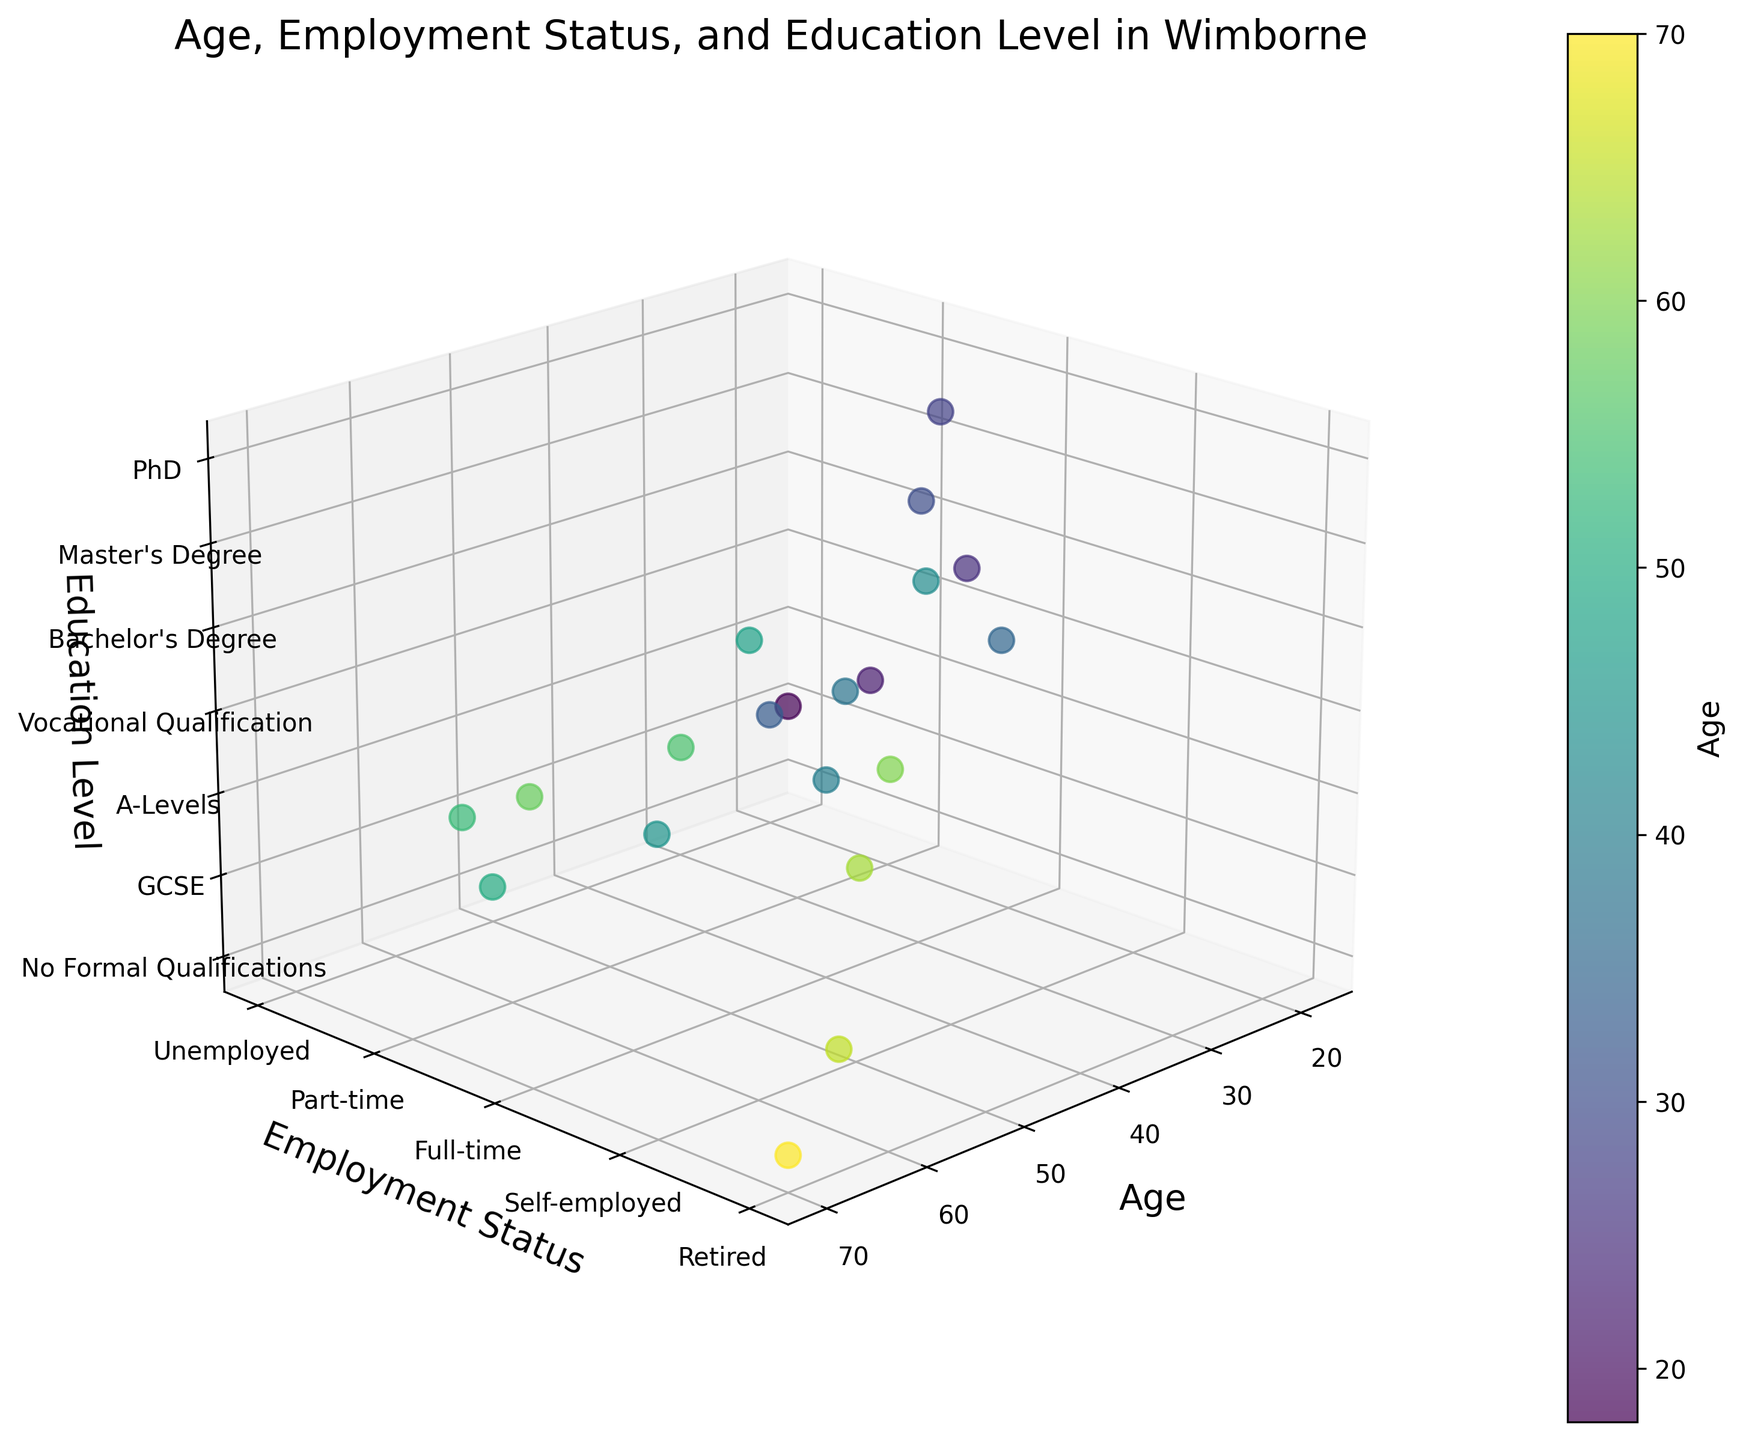What's the title of the figure? The title is located at the top of the figure and often gives a brief description of what the graph is about.
Answer: Age, Employment Status, and Education Level in Wimborne How many employment categories are there in the figure? By looking at the y-axis with labels, there are distinct categories listed for employment status. We count these categories.
Answer: 5 Which education level appears at the highest z-axis position in the plot? The z-axis represents education level, and the highest position would correspond to the highest level labeled on the z-axis.
Answer: PhD At what age do we see the maximum data point count for those with GCSE qualifications? Looking at the z-axis labeled "GCSE" and counting data points at different ages will give you the answer.
Answer: 18, 45, 53, 65 Compare the age and employment status of residents with a Bachelor’s Degree and those with Vocational Qualifications. > Find the data points corresponding to "Bachelor's Degree" and "Vocational Qualification" on the z-axis and compare their positions on the age and y-axis (employment status).
Answer: Residents with a Bachelor's Degree are ages 25, 35, 48, 60, self-employed or full-time. Those with Vocational Qualification are ages 38, 55, 63, full-time or retired What is the average age of full-time employed residents? Identify data points where the y-axis is labeled "Full-time," sum their ages and divide by the number of such points.
Answer: (25+30+40+48+55+38+28)/7 = 264/7 ≈ 37.7 Which age group has the highest diversity in employment status? Examine vertical columns of points at each age and determine which age has points spread across the most employment categories.
Answer: Age 40 has points in Full-time, Self-employed, Unemployed, Part-time, Retired Do retirees have higher or lower education than full-time workers on average? Compare the z-axis values (education levels) for data points of retirees and full-time workers, then average these values for each group to compare.
Answer: Retirees have lower education levels on average compared to full-time workers Are there any age groups with more varied education levels than others? Look at the spread of points on the z-axis for different ages to see which have data points across more education levels.
Answer: Age 30 has varied education levels ranging from GCSE, A-Levels to Master's Degree 